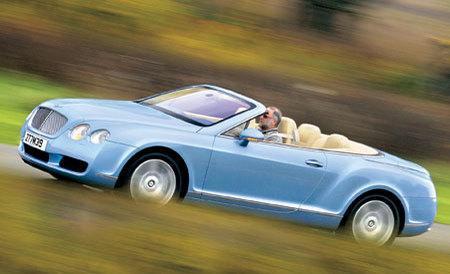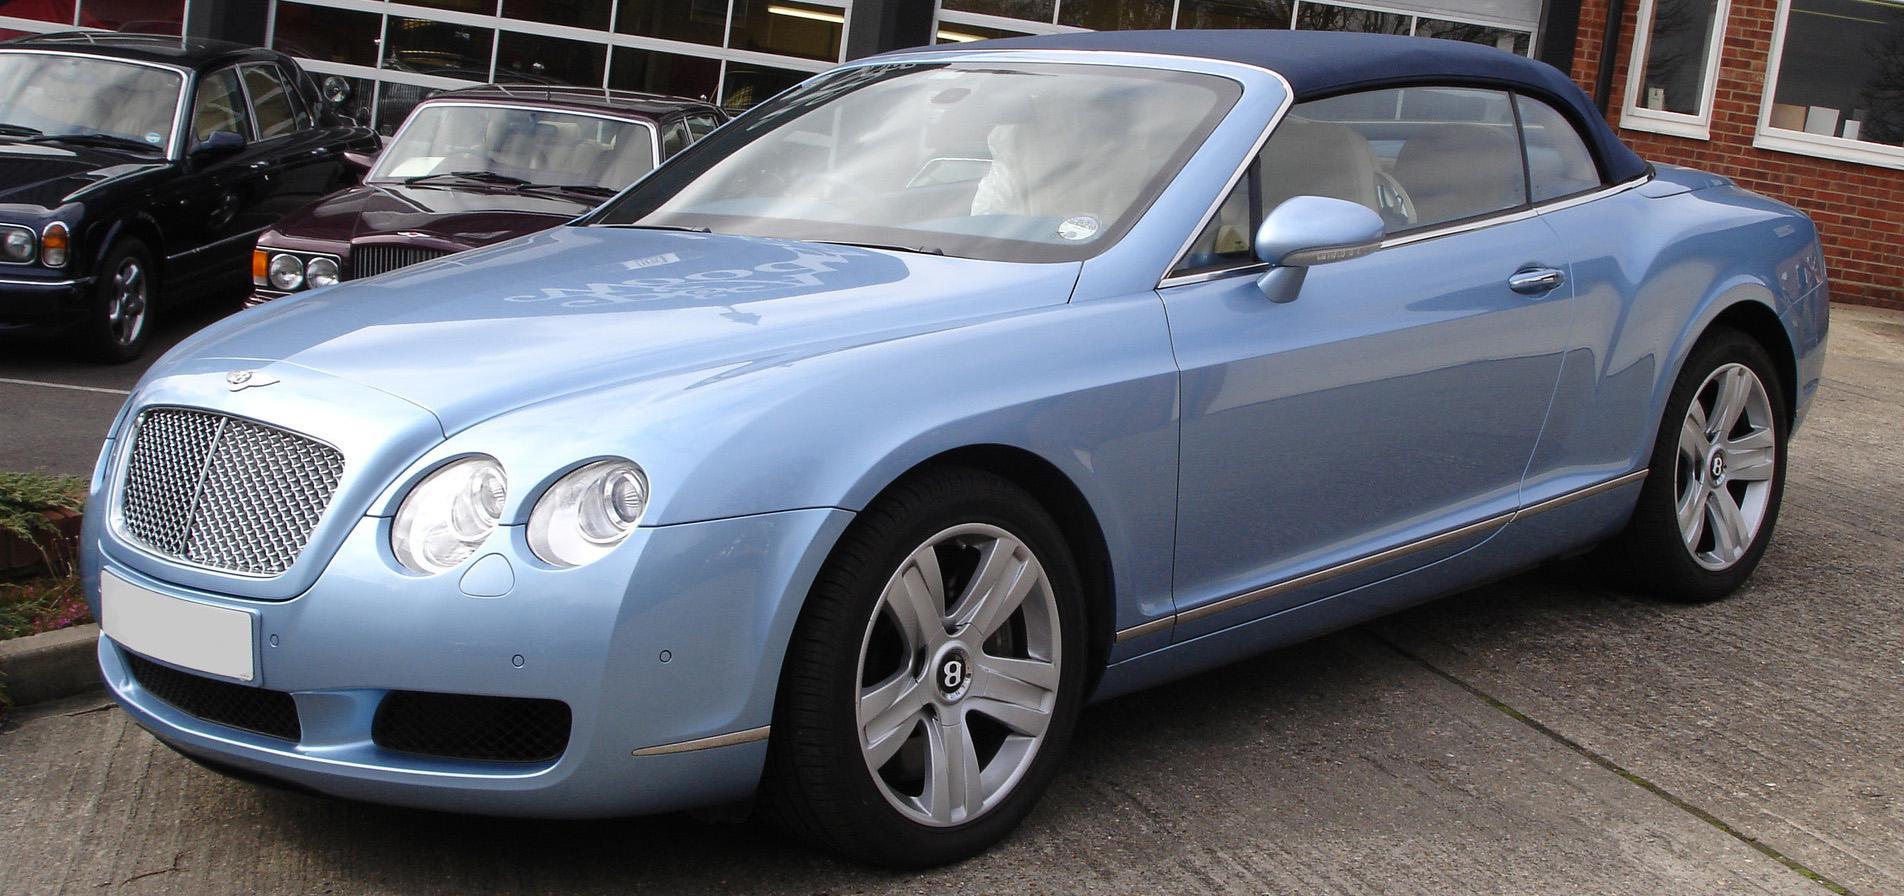The first image is the image on the left, the second image is the image on the right. For the images shown, is this caption "The top is up on the image on the left." true? Answer yes or no. No. 